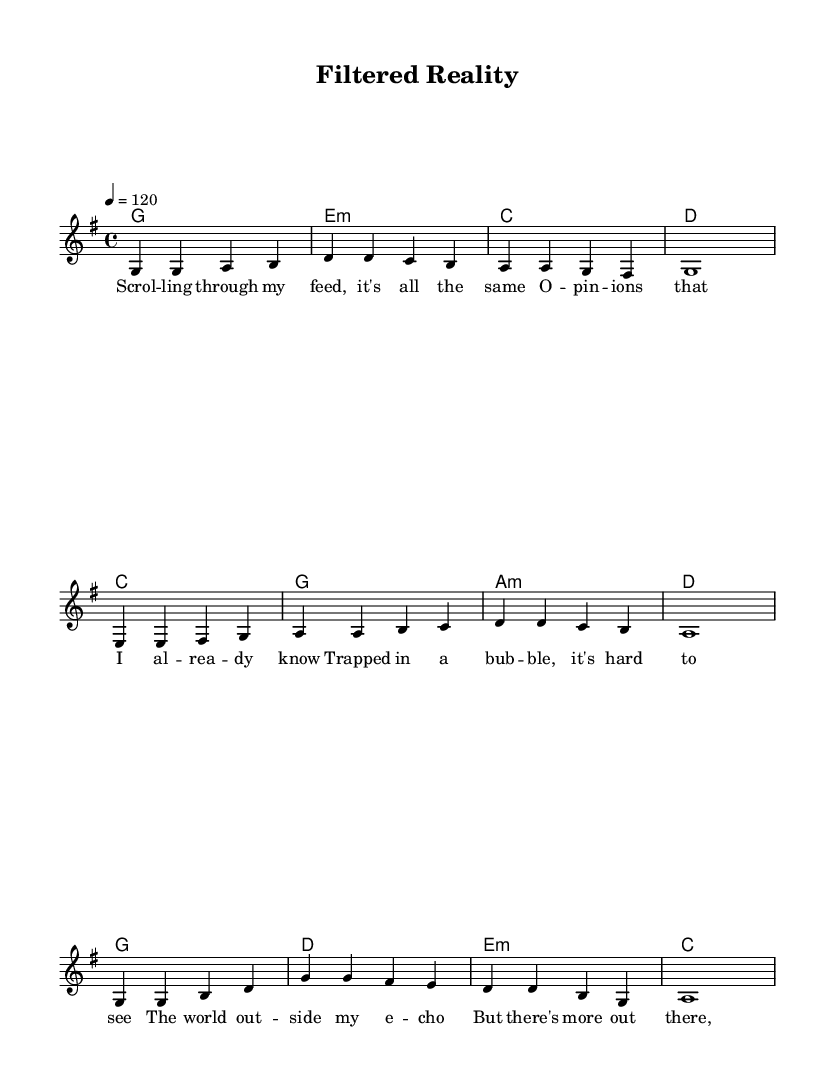What is the key signature of this music? The key signature is one sharp, which indicates that the music is in G major. This can be determined by checking for sharps before the clef symbol at the beginning of the score.
Answer: G major What is the time signature of this music? The time signature is 4/4, which is indicated by the numbers at the beginning of the score after the key signature. This means there are four beats in a measure and a quarter note gets one beat.
Answer: 4/4 What is the tempo marking for the piece? The tempo marking is quarter note equals 120, which is mentioned in the score indicating how fast the music should be played. This can be found in the tempo directive at the beginning of the piece.
Answer: 120 How many measures are in the verse section? The verse section consists of four measures as indicated by the musical notation where the melody and lyrics for the verse are aligned. Counting the bars, we see there are four in total.
Answer: Four What chord follows the G major chord in the verse? The chord that follows the G major chord in the verse is E minor. This is found by looking at the chord symbols written above the melody line, indicating the harmonic progression.
Answer: E minor What is the main theme expressed in the chorus lyrics? The main theme in the chorus lyrics is about breaking free from filter bubbles and seeing the world more clearly. Analyzing the lyrics of the chorus reveals a message about escaping from the constraints of limited viewpoints.
Answer: Breaking free What is the overall structure of the song? The overall structure of the song follows a typical pop format consisting of verse, pre-chorus, and chorus sections. This structure can be identified by the labeled sections in the sheet music with corresponding lyrics.
Answer: Verse, Pre-Chorus, Chorus 